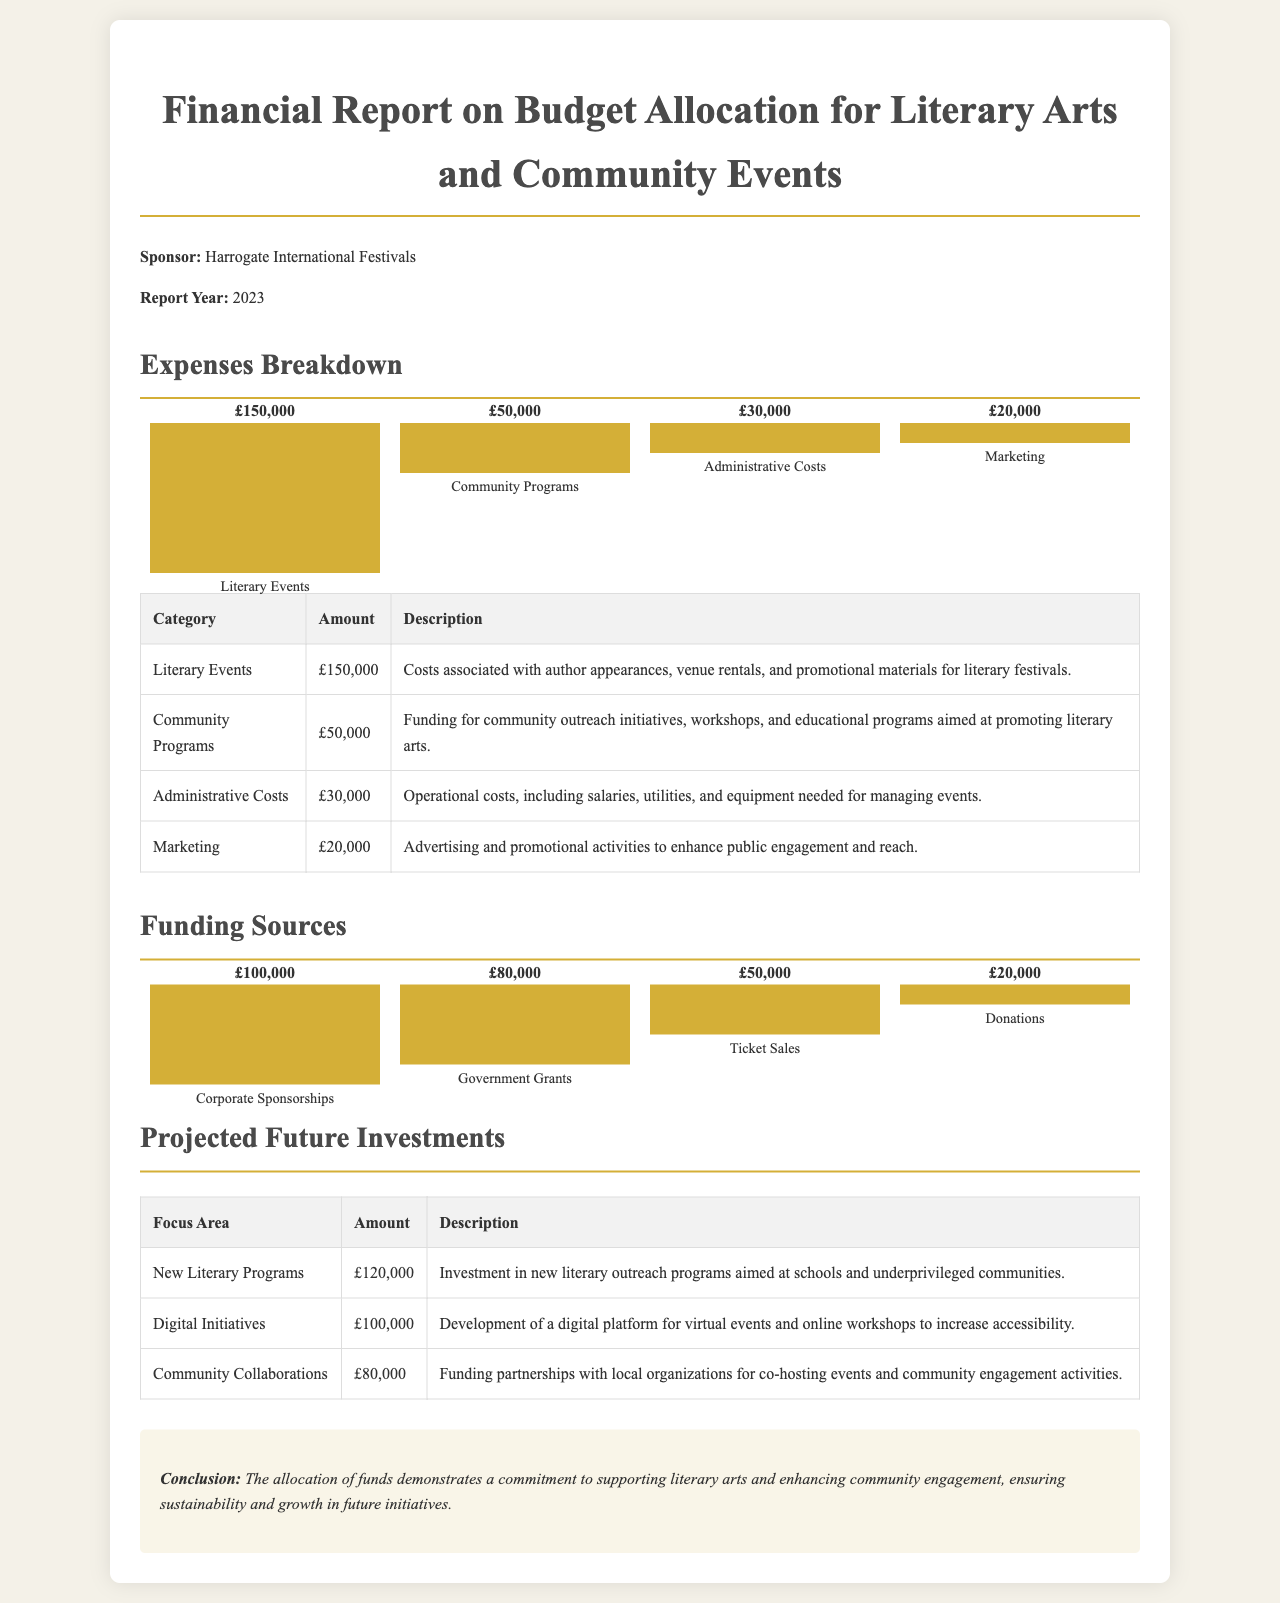What is the total expense for Literary Events? The expense for Literary Events is specifically stated in the document as £150,000.
Answer: £150,000 What are the total projected future investments? The sum of all projected future investments is £120,000 + £100,000 + £80,000 = £300,000.
Answer: £300,000 How much funding comes from Corporate Sponsorships? The document states that funding from Corporate Sponsorships is £100,000.
Answer: £100,000 What is the expense allocated for Community Programs? The document indicates that the expense for Community Programs is £50,000.
Answer: £50,000 Which area has the highest future investment? The focus area with the highest projected future investment is New Literary Programs at £120,000.
Answer: New Literary Programs What is the total amount spent on Administrative Costs and Marketing combined? The combined expenses for Administrative Costs (£30,000) and Marketing (£20,000) equals £50,000.
Answer: £50,000 What is the total amount from Donations? The total amount from Donations, as noted in the document, is £20,000.
Answer: £20,000 What were the total expenses for the document year? The total expenses are the sum of all individual expenses: £150,000 + £50,000 + £30,000 + £20,000 = £250,000.
Answer: £250,000 Which category has the lowest expenses? The category with the lowest expenses is Marketing with £20,000.
Answer: Marketing 